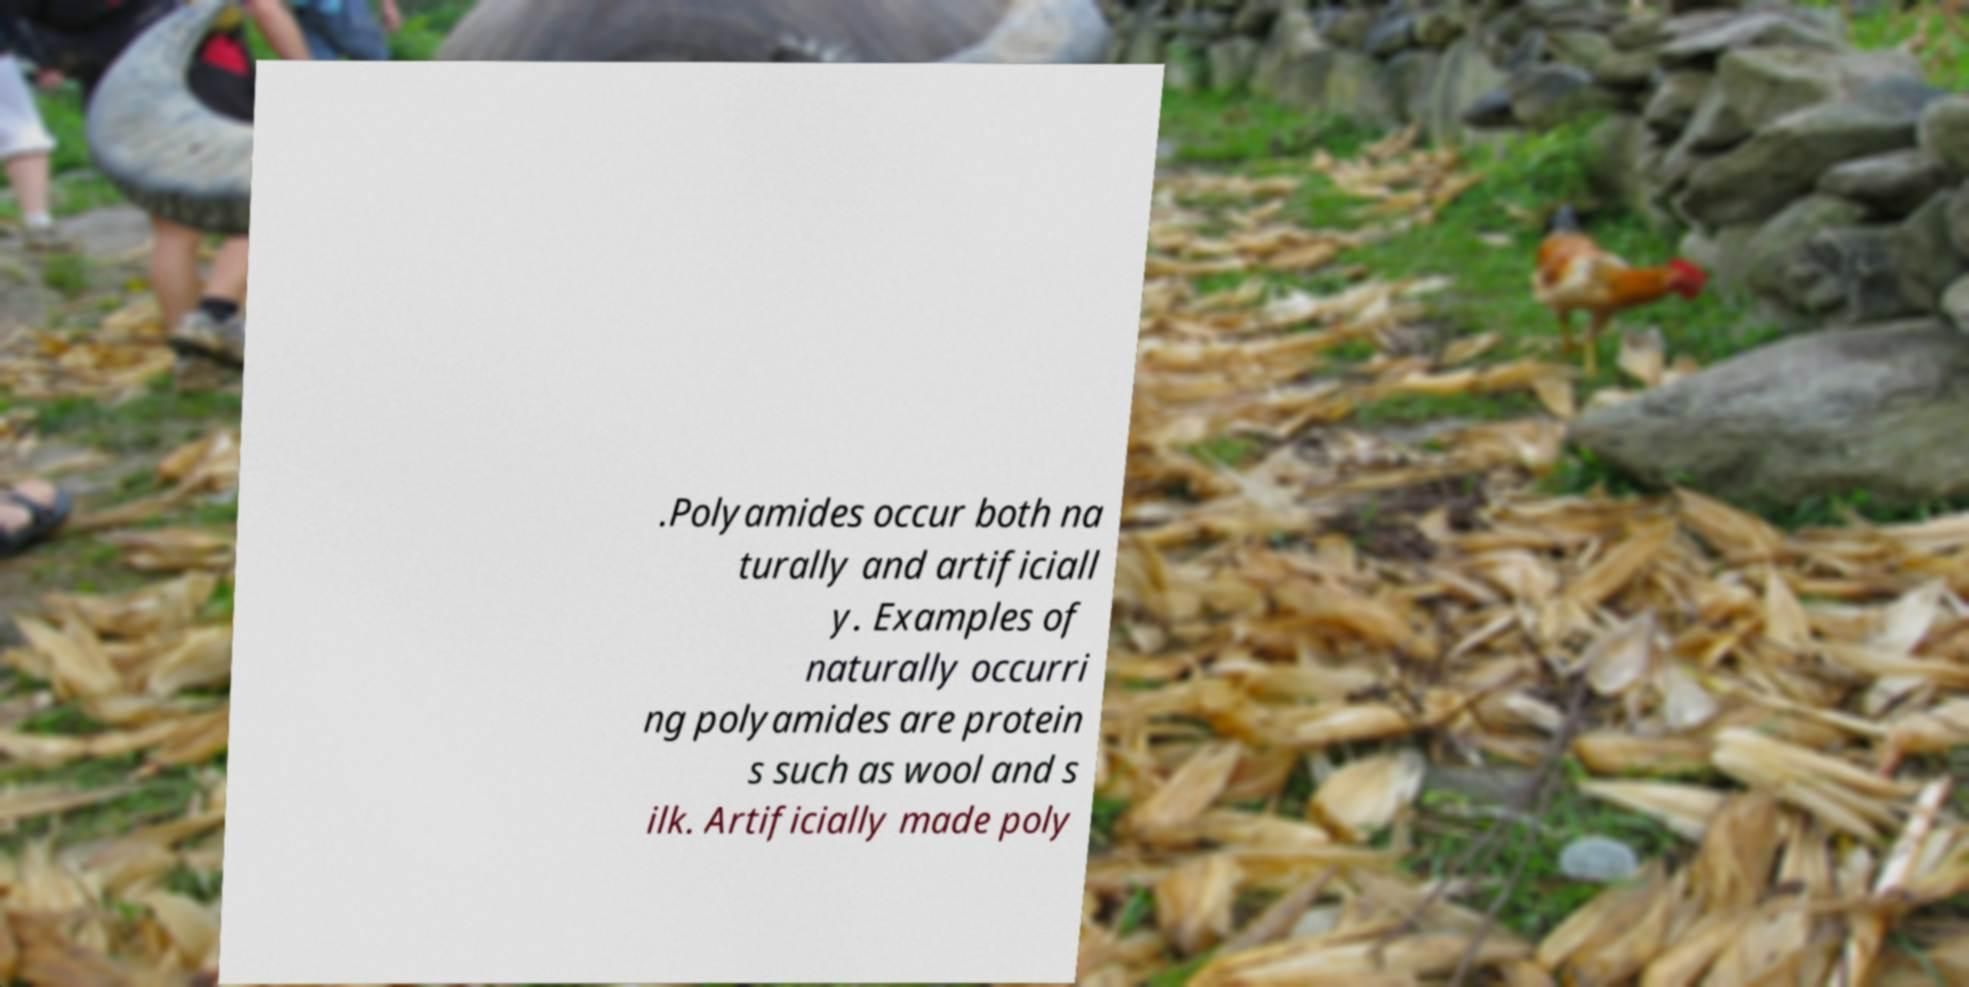Could you extract and type out the text from this image? .Polyamides occur both na turally and artificiall y. Examples of naturally occurri ng polyamides are protein s such as wool and s ilk. Artificially made poly 